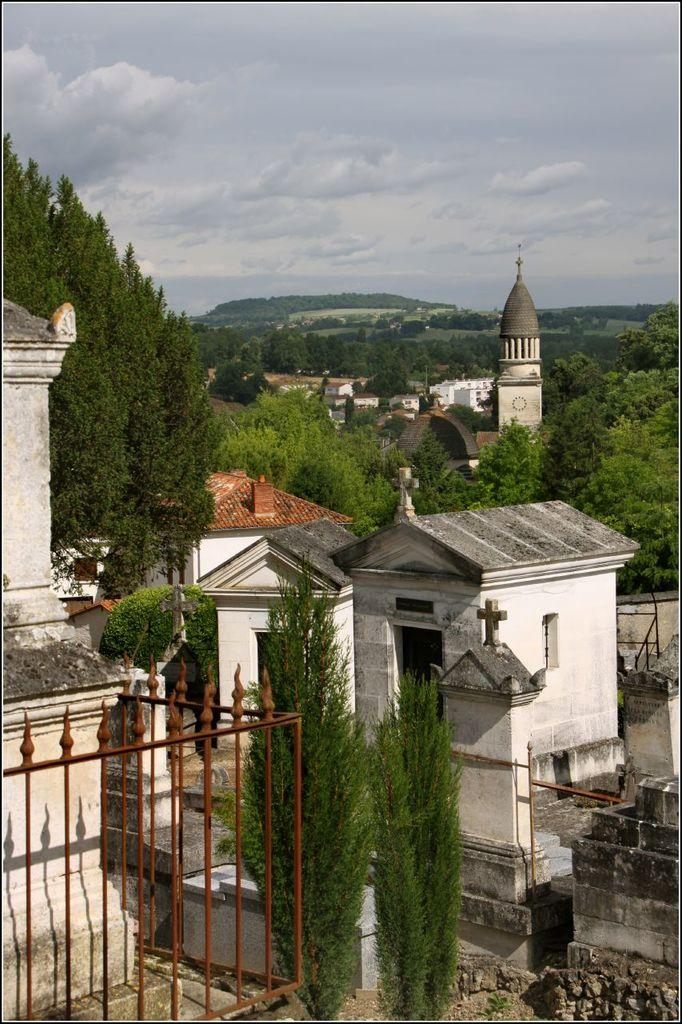What type of structures can be seen in the image? There are buildings in the image. What natural elements are present in the image? There are trees and a hill in the image. What is visible at the top of the image? The sky is visible at the top of the image, and it is cloudy. What architectural feature can be seen at the bottom of the image? There is an iron grille at the bottom of the image. How many snakes are slithering on the hill in the image? There are no snakes present in the image; it features buildings, trees, a hill, and an iron grille. What breed of dog can be seen playing near the trees in the image? There is no dog present in the image; it only features buildings, trees, a hill, and an iron grille. 